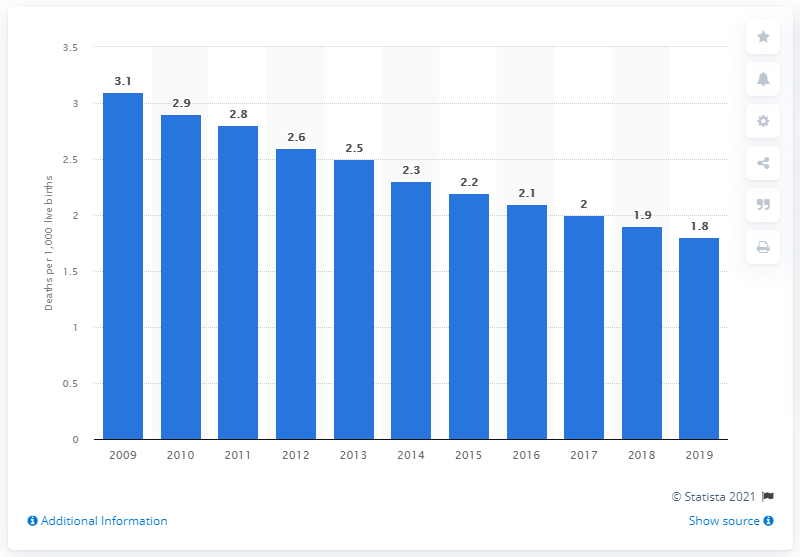Point out several critical features in this image. In 2019, the infant mortality rate in Cyprus was 1.8 per 1,000 live births. 